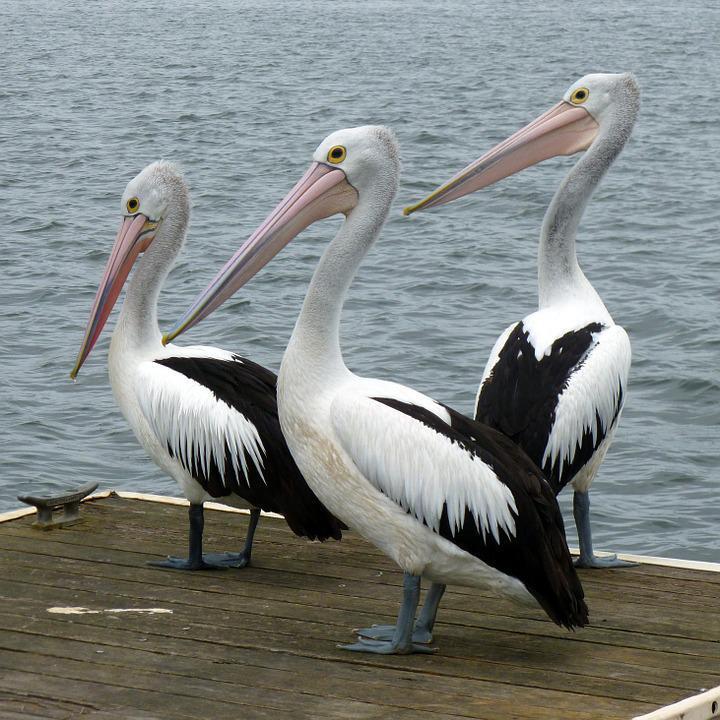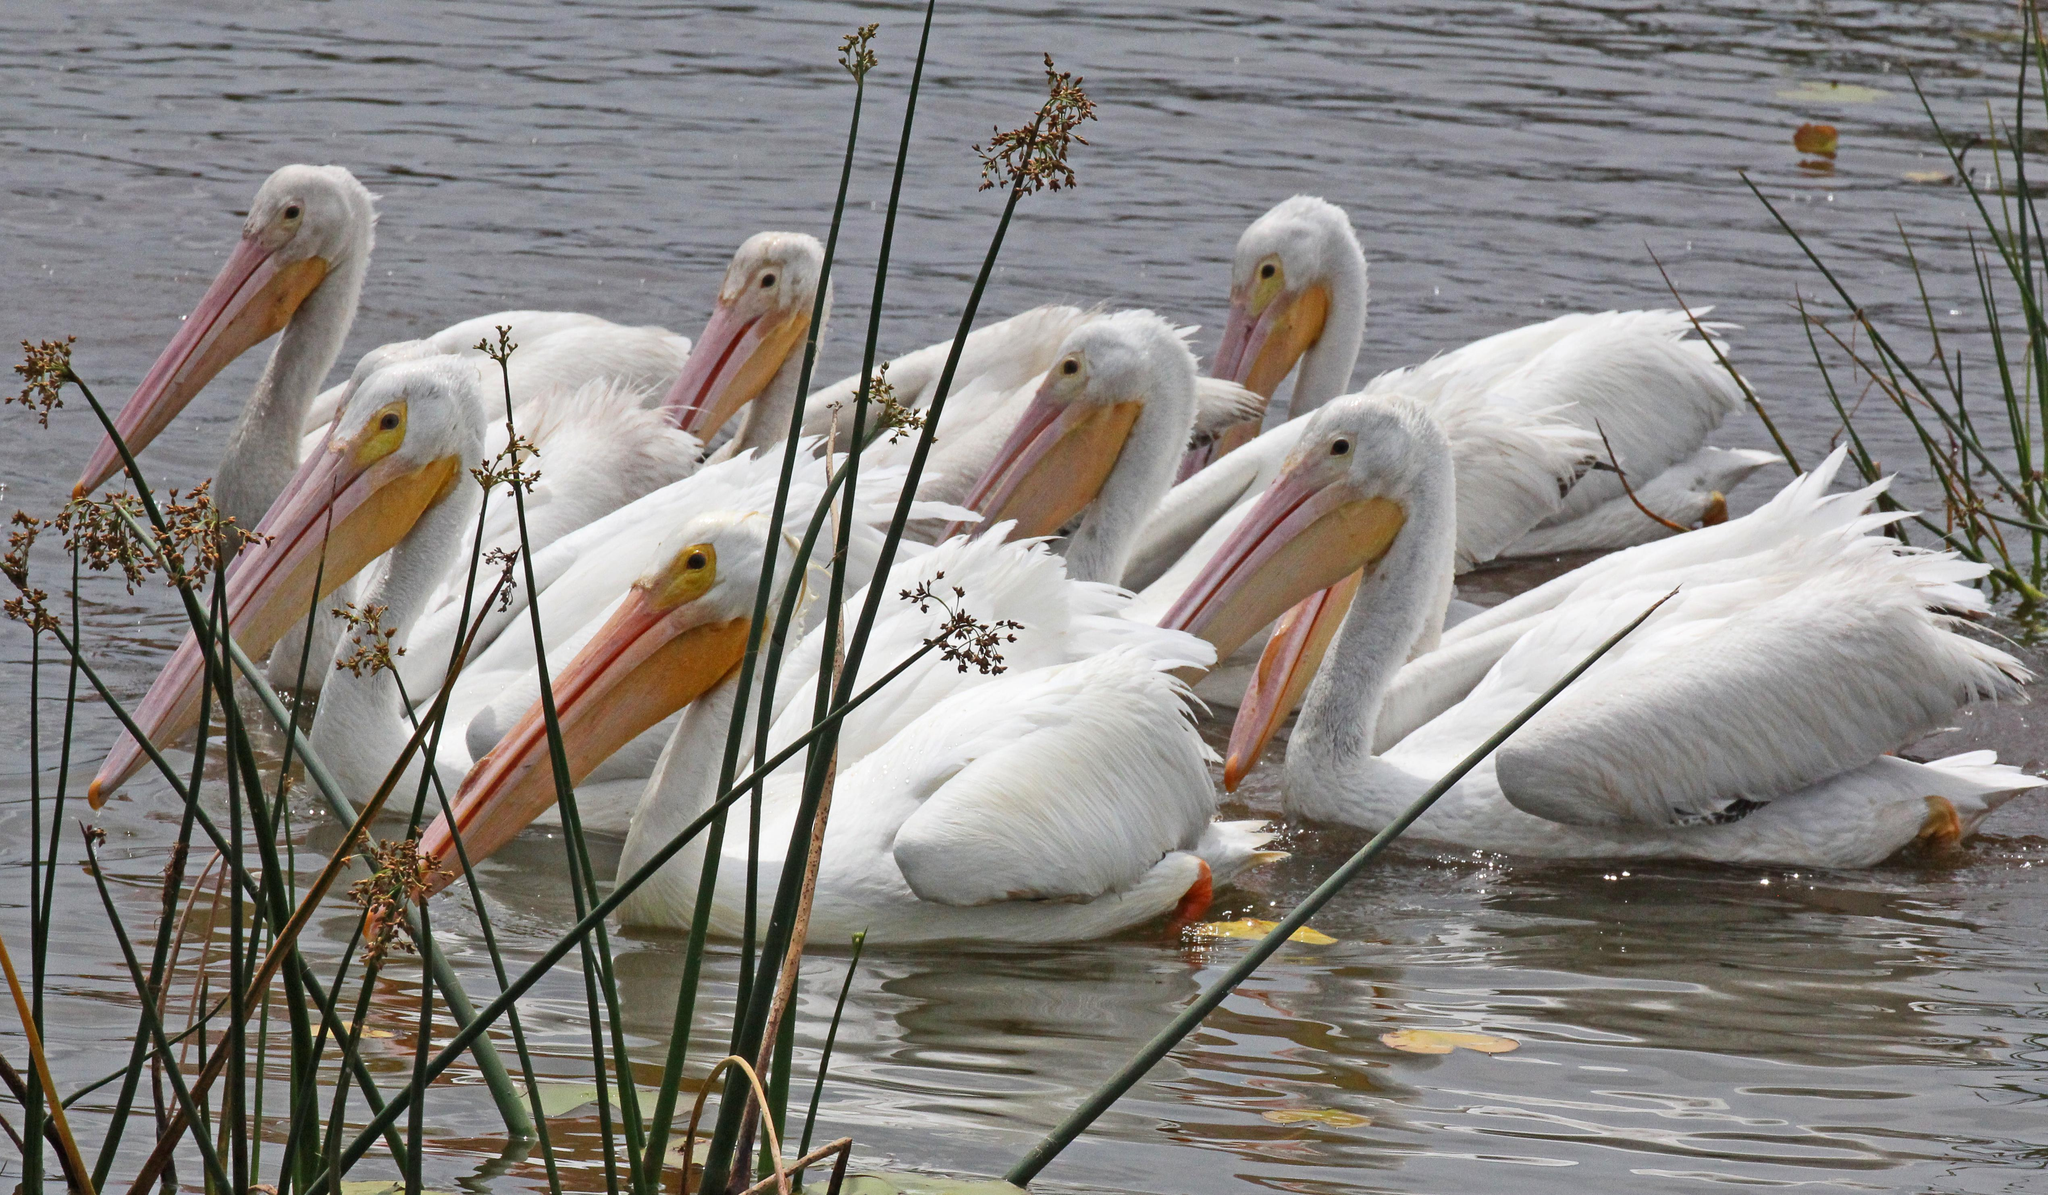The first image is the image on the left, the second image is the image on the right. Evaluate the accuracy of this statement regarding the images: "There are exactly three pelicans in one of the images". Is it true? Answer yes or no. Yes. The first image is the image on the left, the second image is the image on the right. Examine the images to the left and right. Is the description "There are 3 storks on the left image" accurate? Answer yes or no. Yes. 